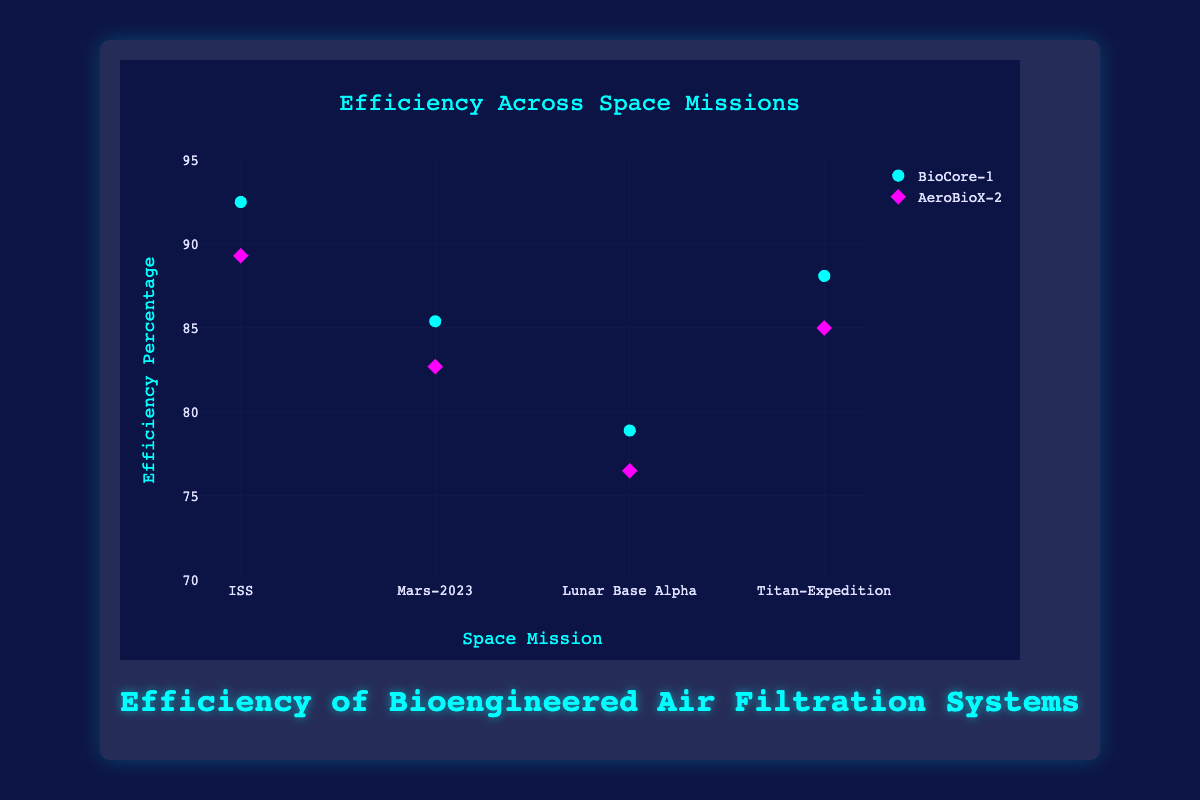What is the title of the chart? Look at the top of the chart, the text in a larger font is the title.
Answer: Efficiency Across Space Missions What is the x-axis labeled as? Look at the bottom of the chart, near the horizontal axis, where the axis title appears.
Answer: Space Mission What is the highest efficiency percentage recorded on the chart? Identify the data point that reaches the maximum height on the y-axis.
Answer: 92.5% Which filter system generally has higher efficiency percentages across all missions? Compare the positions of markers for "BioCore-1" and "AeroBioX-2" on the y-axis. "BioCore-1" markers generally appear higher than "AeroBioX-2".
Answer: BioCore-1 How does the efficiency of BioCore-1 compare between the ISS mission and the Mars-2023 mission? Locate the BioCore-1 markers for ISS (92.5%) and Mars-2023 (85.4%) and compare their heights.
Answer: ISS has higher efficiency than Mars-2023 What is the average efficiency percentage of AeroBioX-2 across all missions? Add the efficiency percentages for AeroBioX-2 (89.3 + 82.7 + 76.5 + 85.0) and divide by the number of missions (4). So, (89.3 + 82.7 + 76.5 + 85.0) / 4 = 83.375
Answer: 83.375% Which missions have atmospheric compositions that contain Methane? Check the hover text for each data point and identify missions with "Methane" listed.
Answer: Mars-2023, Titan-Expedition Which filter system shows more variation in efficiency percentages, BioCore-1 or AeroBioX-2? Calculate the range (max - min) of efficiency percentages for both systems. For BioCore-1: 92.5 - 78.9 = 13.6; For AeroBioX-2: 89.3 - 76.5 = 12.8.
Answer: BioCore-1 Among BioCore-1 and AeroBioX-2, which filter system has the least efficient performance and on which mission? Identify the lowest efficiency percentage and the corresponding system and mission.
Answer: AeroBioX-2 on Lunar Base Alpha How does the efficiency of each filter system on the Titan-Expedition compare to their efficiency on the ISS? Compare the efficiencies for BioCore-1 (ISS: 92.5, Titan-Expedition: 88.1) and AeroBioX-2 (ISS: 89.3, Titan-Expedition: 85.0). Both systems are less efficient on Titan-Expedition than on the ISS.
Answer: Lower on Titan-Expedition for both 